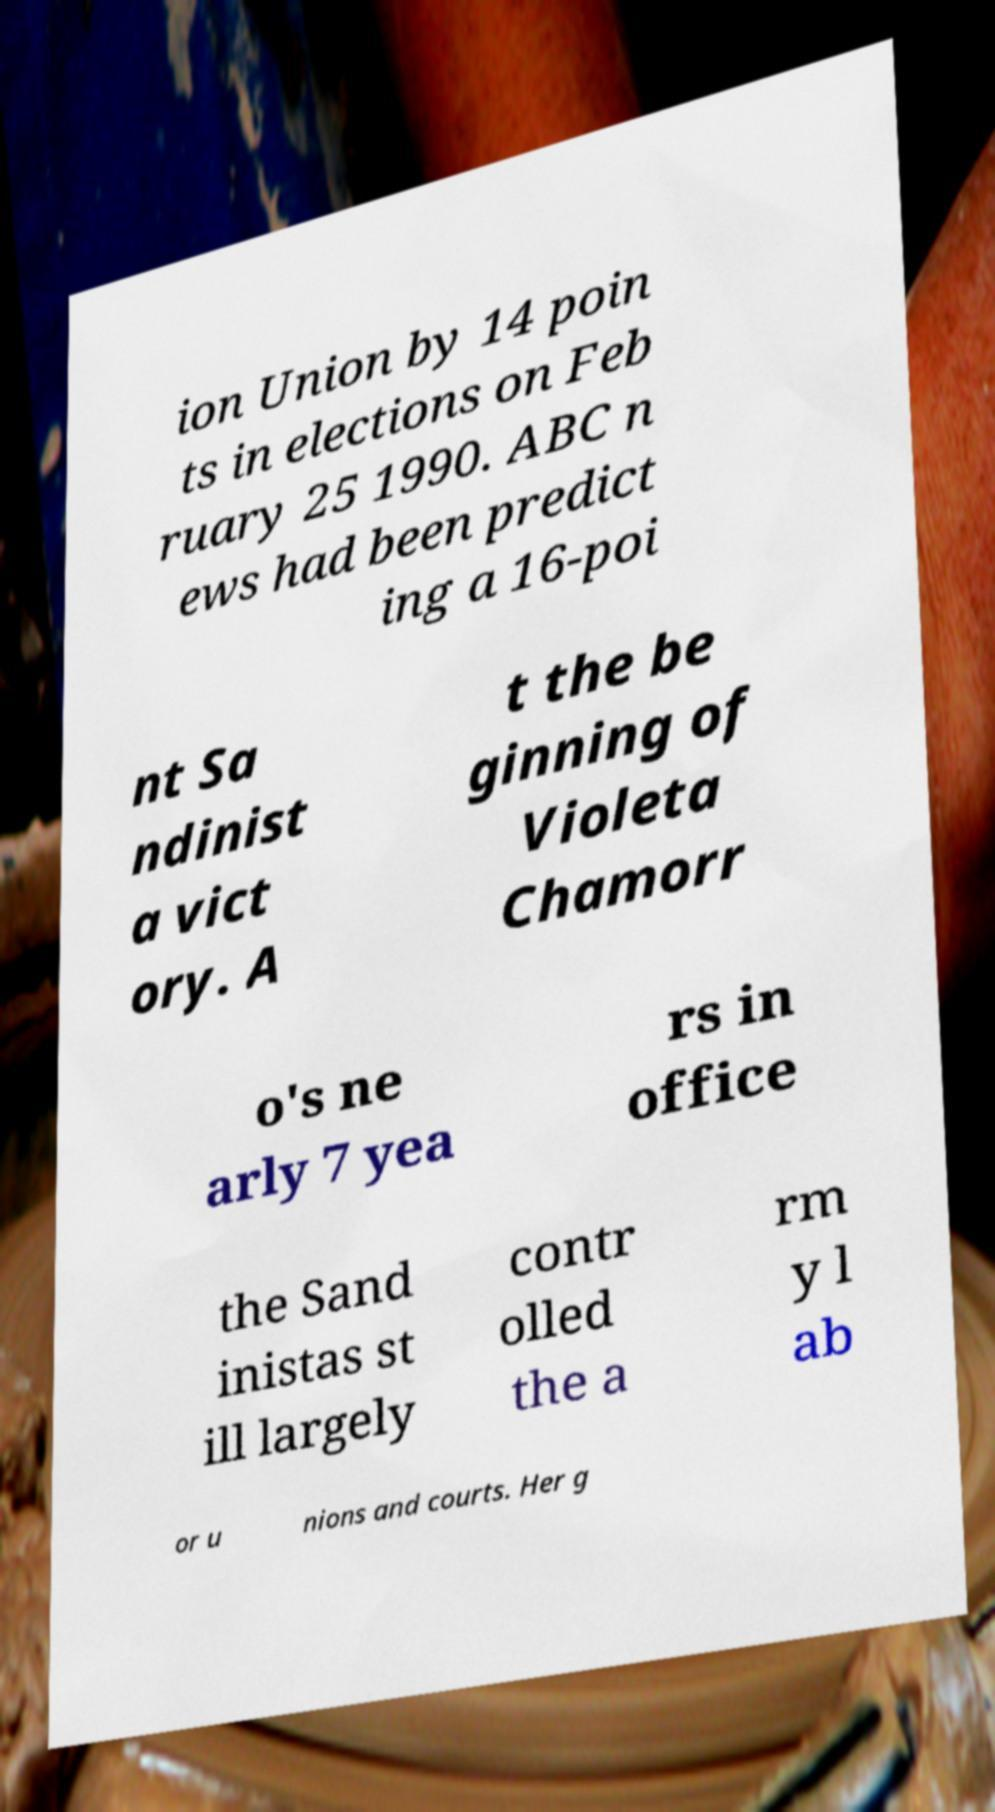There's text embedded in this image that I need extracted. Can you transcribe it verbatim? ion Union by 14 poin ts in elections on Feb ruary 25 1990. ABC n ews had been predict ing a 16-poi nt Sa ndinist a vict ory. A t the be ginning of Violeta Chamorr o's ne arly 7 yea rs in office the Sand inistas st ill largely contr olled the a rm y l ab or u nions and courts. Her g 